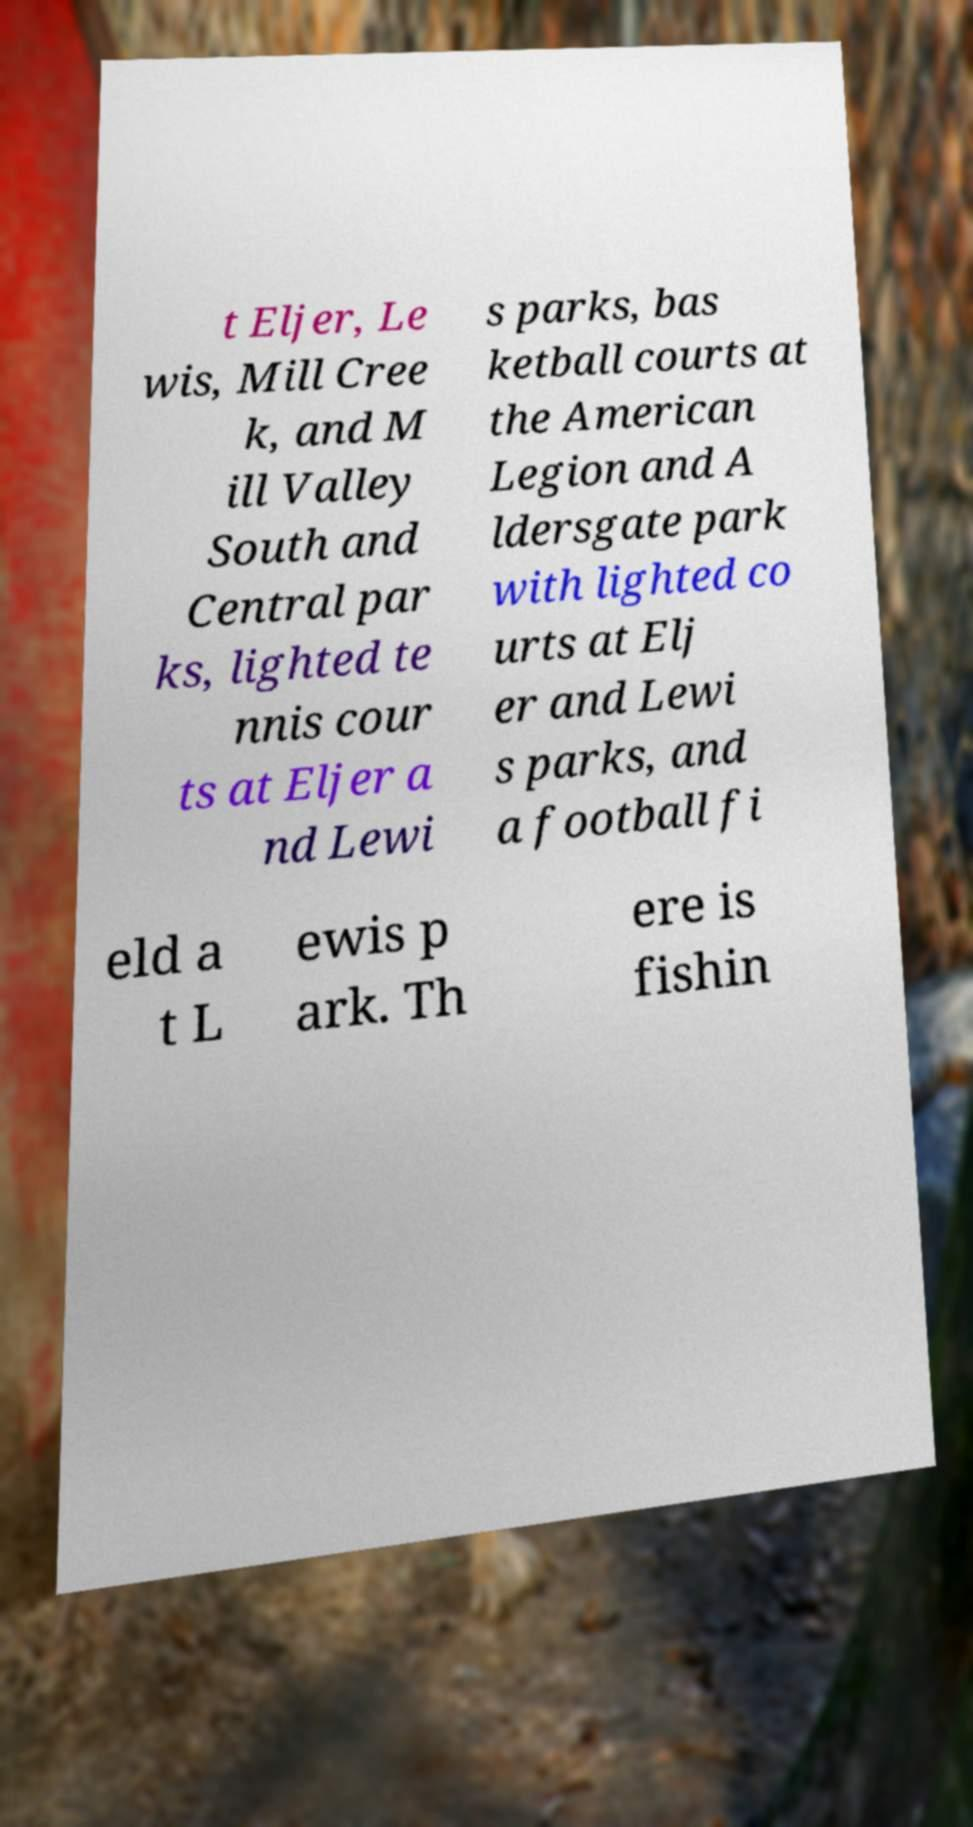Please identify and transcribe the text found in this image. t Eljer, Le wis, Mill Cree k, and M ill Valley South and Central par ks, lighted te nnis cour ts at Eljer a nd Lewi s parks, bas ketball courts at the American Legion and A ldersgate park with lighted co urts at Elj er and Lewi s parks, and a football fi eld a t L ewis p ark. Th ere is fishin 